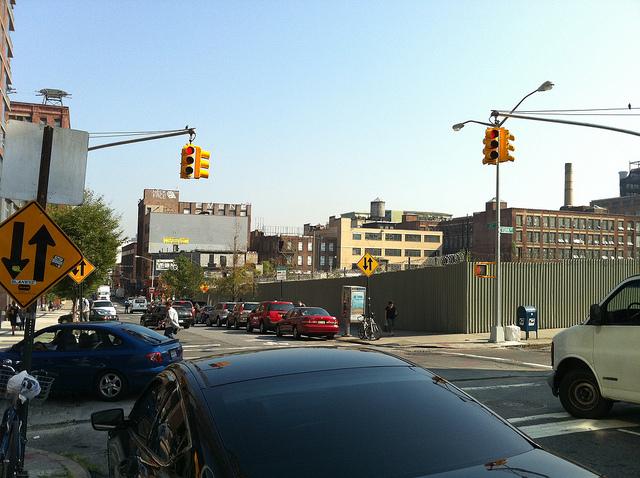According to the stoplight, are the cars supposed to be going or stopping?
Short answer required. Stopping. Where is the USPS box?
Keep it brief. Corner. What city is this?
Answer briefly. New york. 